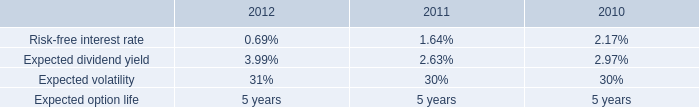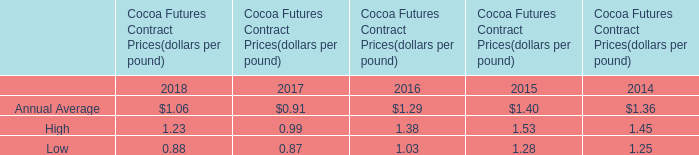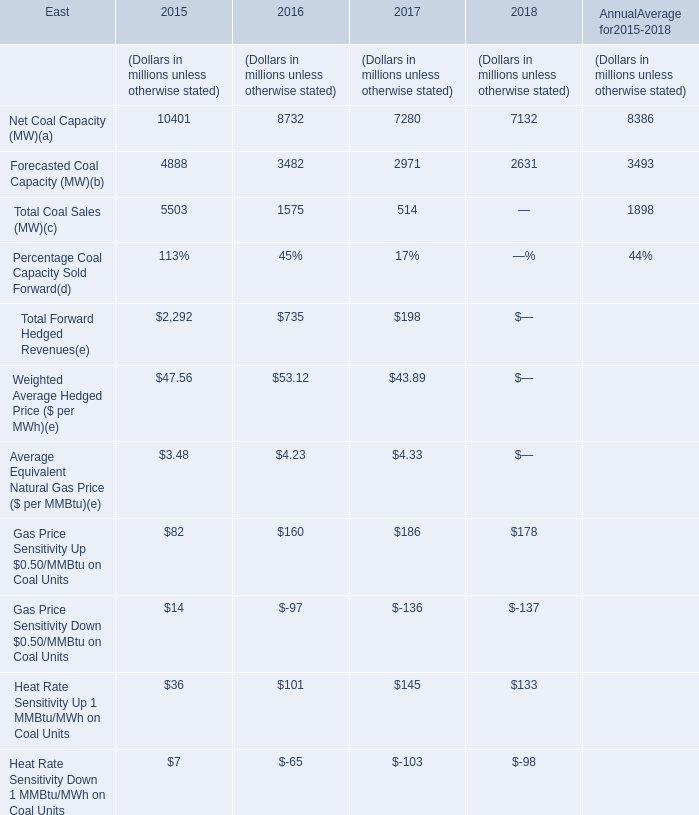How many kinds of Net Coal Capacity and Fore casted Coal Capacity are greater than 7000 in 2015? 
Answer: 1. 